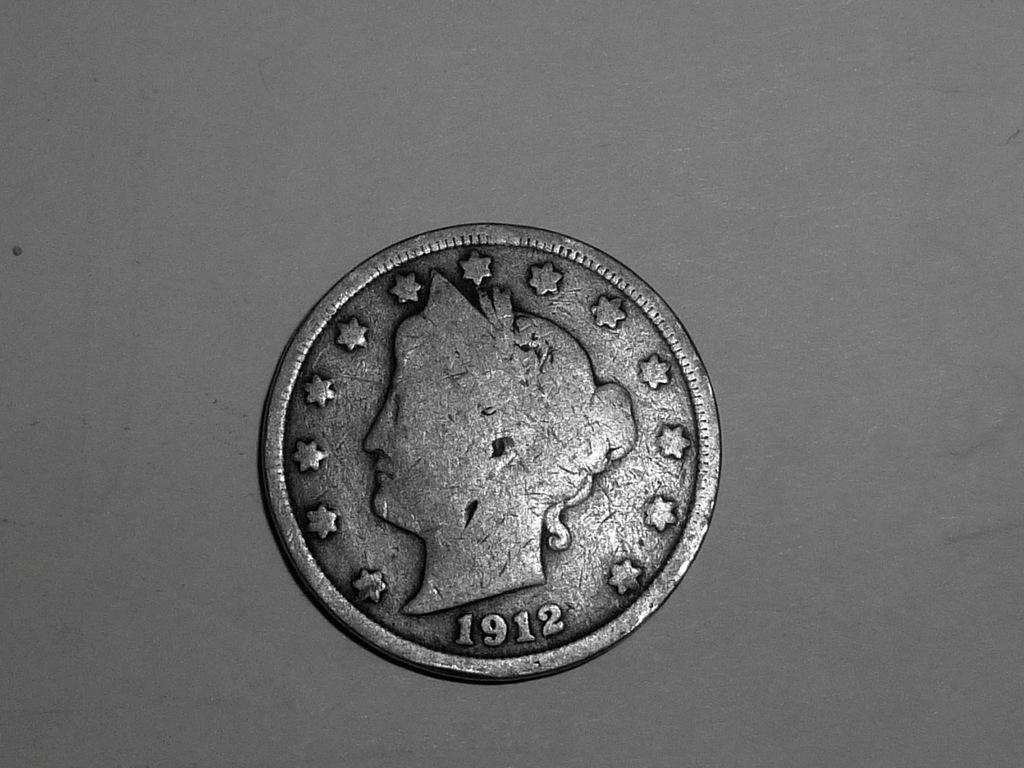What year is on this coin?
Offer a terse response. 1912. 